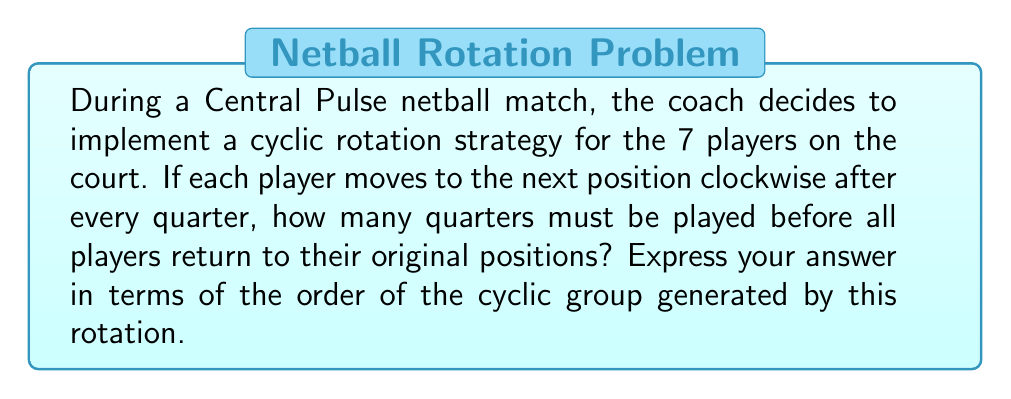Solve this math problem. Let's approach this step-by-step:

1) First, we need to understand that this rotation can be modeled as a cyclic group. Let's call the group $G$.

2) The group operation here is the rotation of players. Each rotation moves every player one position clockwise.

3) Let $r$ represent one complete rotation. Then, the elements of the group are:
   $G = \{e, r, r^2, r^3, r^4, r^5, r^6\}$
   where $e$ is the identity element (no rotation).

4) The order of this group is 7, as there are 7 distinct elements. We can denote this as $|G| = 7$.

5) In group theory, for any element $a$ in a group, the smallest positive integer $n$ such that $a^n = e$ is called the order of $a$.

6) In this case, we want to find the smallest positive integer $n$ such that $r^n = e$, which would mean all players have returned to their original positions.

7) Since the group is cyclic and has order 7, we know that $r^7 = e$.

8) Moreover, 7 is a prime number, which means that for any smaller positive integer $k < 7$, $r^k \neq e$.

9) Therefore, the smallest number of rotations needed to return all players to their original positions is 7.

10) Since each rotation occurs after a quarter, the number of quarters needed is also 7.

11) This number 7 is precisely the order of the cyclic group $G$.
Answer: The number of quarters needed is 7, which is equal to the order of the cyclic group $|G|$. 